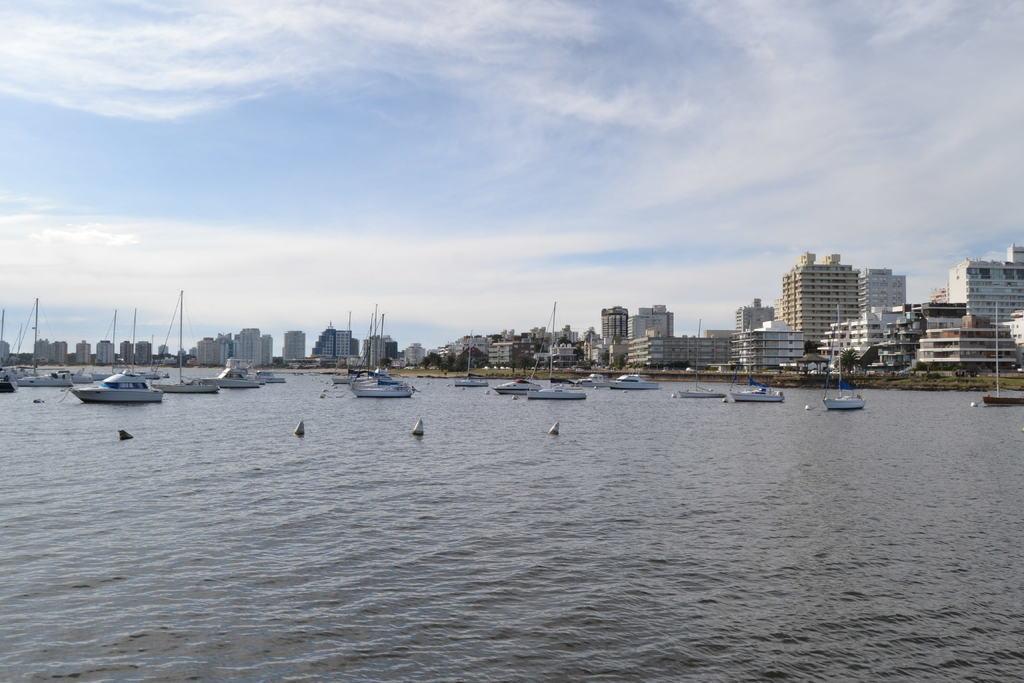How would you summarize this image in a sentence or two? In this image I can see few ships on the water. Back Side I can see buildings,poles and trees. The sky is in blue and white color. 